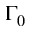<formula> <loc_0><loc_0><loc_500><loc_500>\Gamma _ { 0 }</formula> 